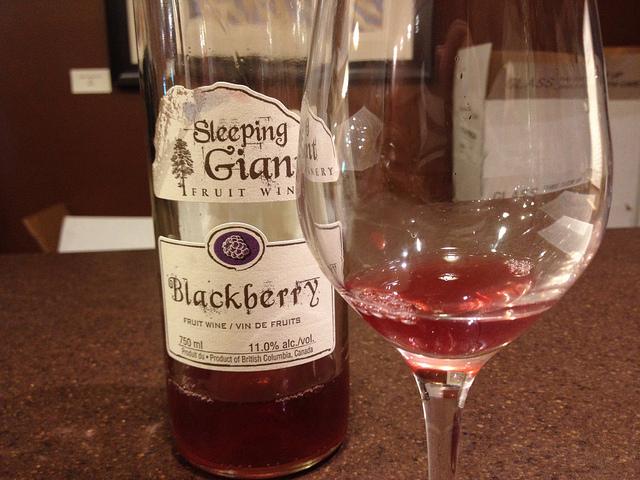What type of beverage is in the glass?
Write a very short answer. Wine. What name is on the bottle?
Concise answer only. Sleeping giant. What is the alcohol content of this wine?
Concise answer only. 11.0%. Is the glass full?
Keep it brief. No. 